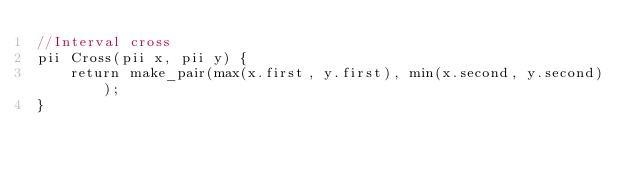<code> <loc_0><loc_0><loc_500><loc_500><_C++_>//Interval cross
pii Cross(pii x, pii y) {
    return make_pair(max(x.first, y.first), min(x.second, y.second));
}

</code> 